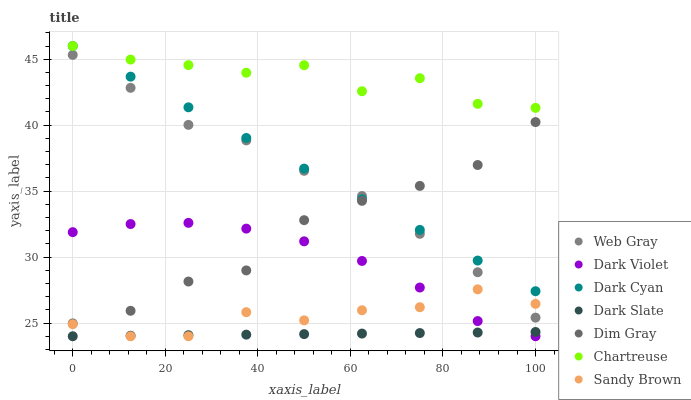Does Dark Slate have the minimum area under the curve?
Answer yes or no. Yes. Does Chartreuse have the maximum area under the curve?
Answer yes or no. Yes. Does Dark Violet have the minimum area under the curve?
Answer yes or no. No. Does Dark Violet have the maximum area under the curve?
Answer yes or no. No. Is Dark Slate the smoothest?
Answer yes or no. Yes. Is Chartreuse the roughest?
Answer yes or no. Yes. Is Dark Violet the smoothest?
Answer yes or no. No. Is Dark Violet the roughest?
Answer yes or no. No. Does Dark Violet have the lowest value?
Answer yes or no. Yes. Does Chartreuse have the lowest value?
Answer yes or no. No. Does Dark Cyan have the highest value?
Answer yes or no. Yes. Does Dark Violet have the highest value?
Answer yes or no. No. Is Dark Slate less than Dark Cyan?
Answer yes or no. Yes. Is Dim Gray greater than Sandy Brown?
Answer yes or no. Yes. Does Dim Gray intersect Web Gray?
Answer yes or no. Yes. Is Dim Gray less than Web Gray?
Answer yes or no. No. Is Dim Gray greater than Web Gray?
Answer yes or no. No. Does Dark Slate intersect Dark Cyan?
Answer yes or no. No. 